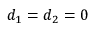<formula> <loc_0><loc_0><loc_500><loc_500>d _ { 1 } = d _ { 2 } = 0</formula> 